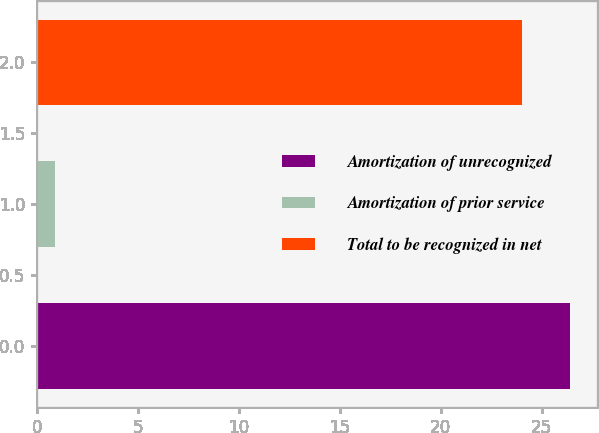<chart> <loc_0><loc_0><loc_500><loc_500><bar_chart><fcel>Amortization of unrecognized<fcel>Amortization of prior service<fcel>Total to be recognized in net<nl><fcel>26.4<fcel>0.9<fcel>24<nl></chart> 